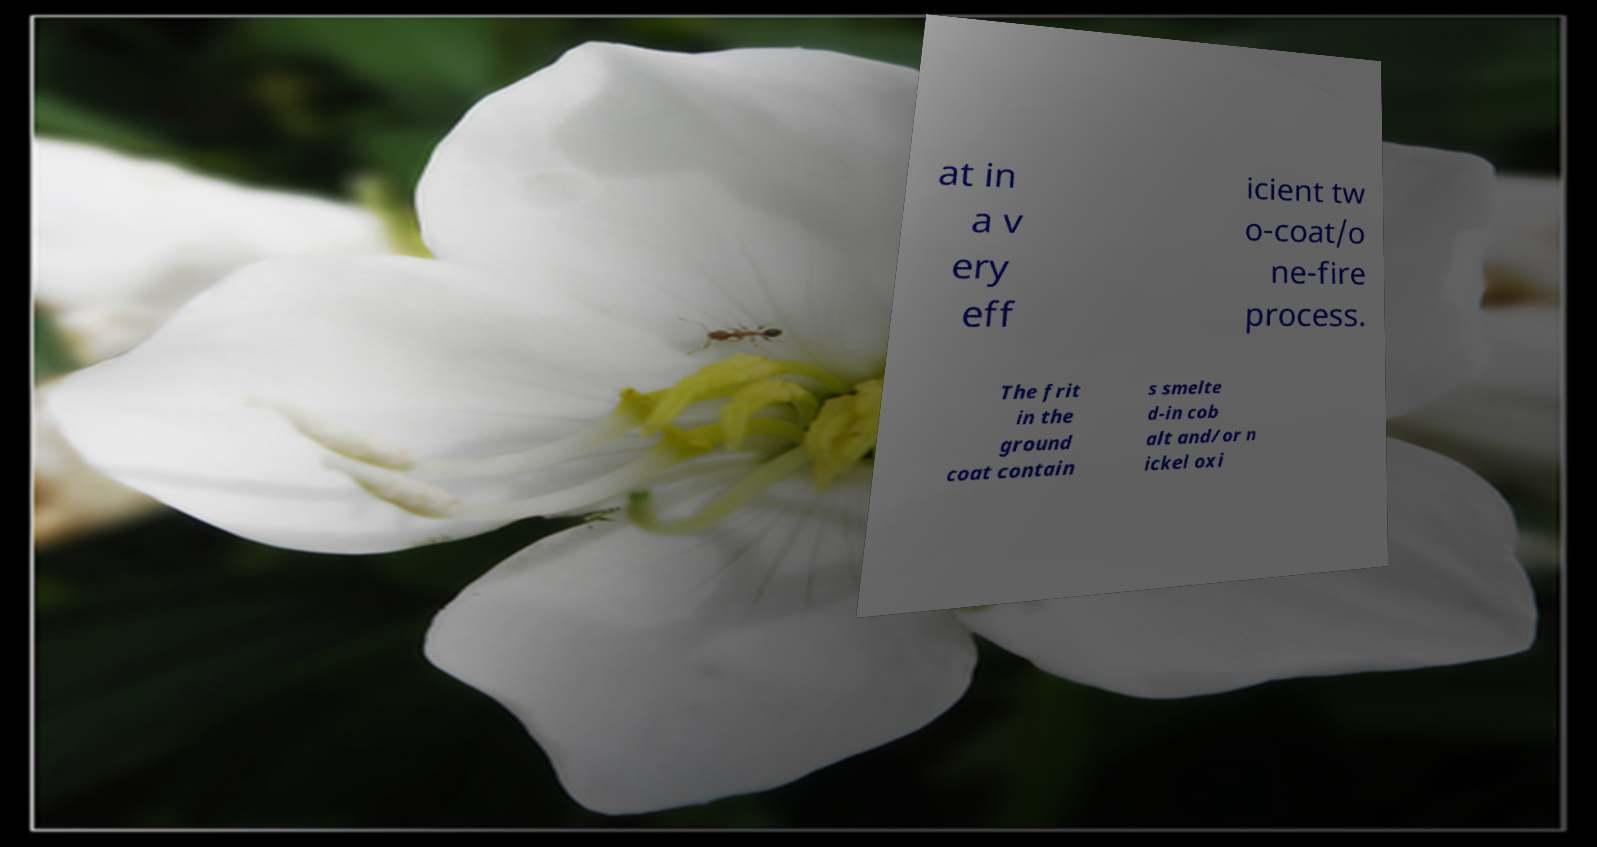I need the written content from this picture converted into text. Can you do that? at in a v ery eff icient tw o-coat/o ne-fire process. The frit in the ground coat contain s smelte d-in cob alt and/or n ickel oxi 